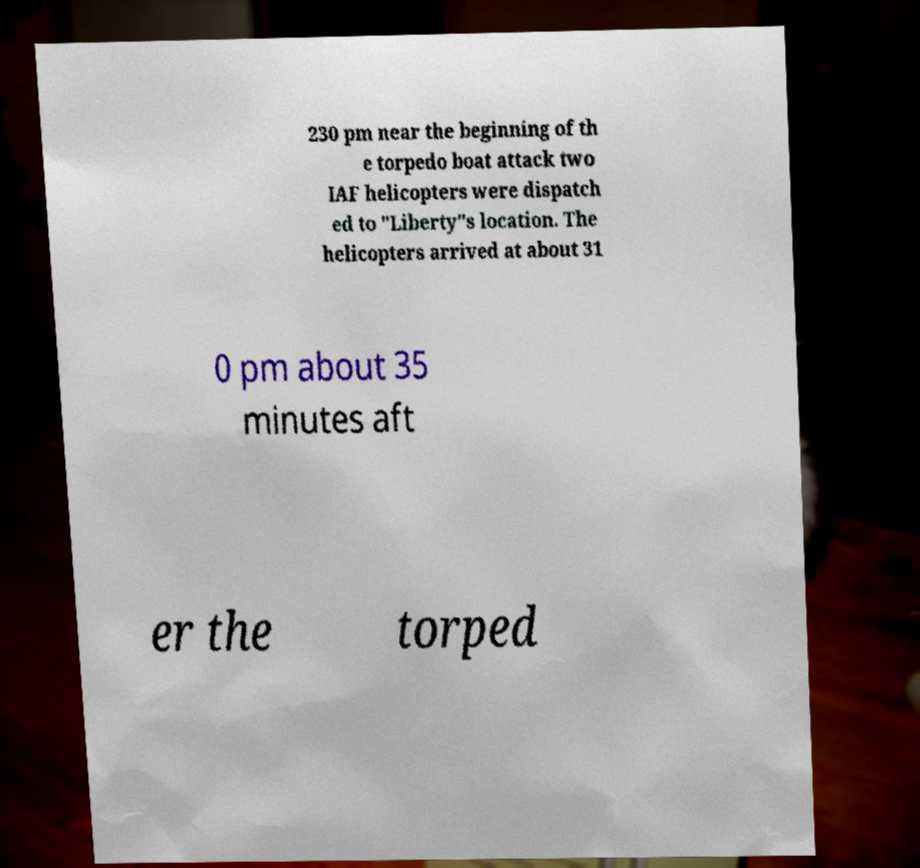Could you assist in decoding the text presented in this image and type it out clearly? 230 pm near the beginning of th e torpedo boat attack two IAF helicopters were dispatch ed to "Liberty"s location. The helicopters arrived at about 31 0 pm about 35 minutes aft er the torped 